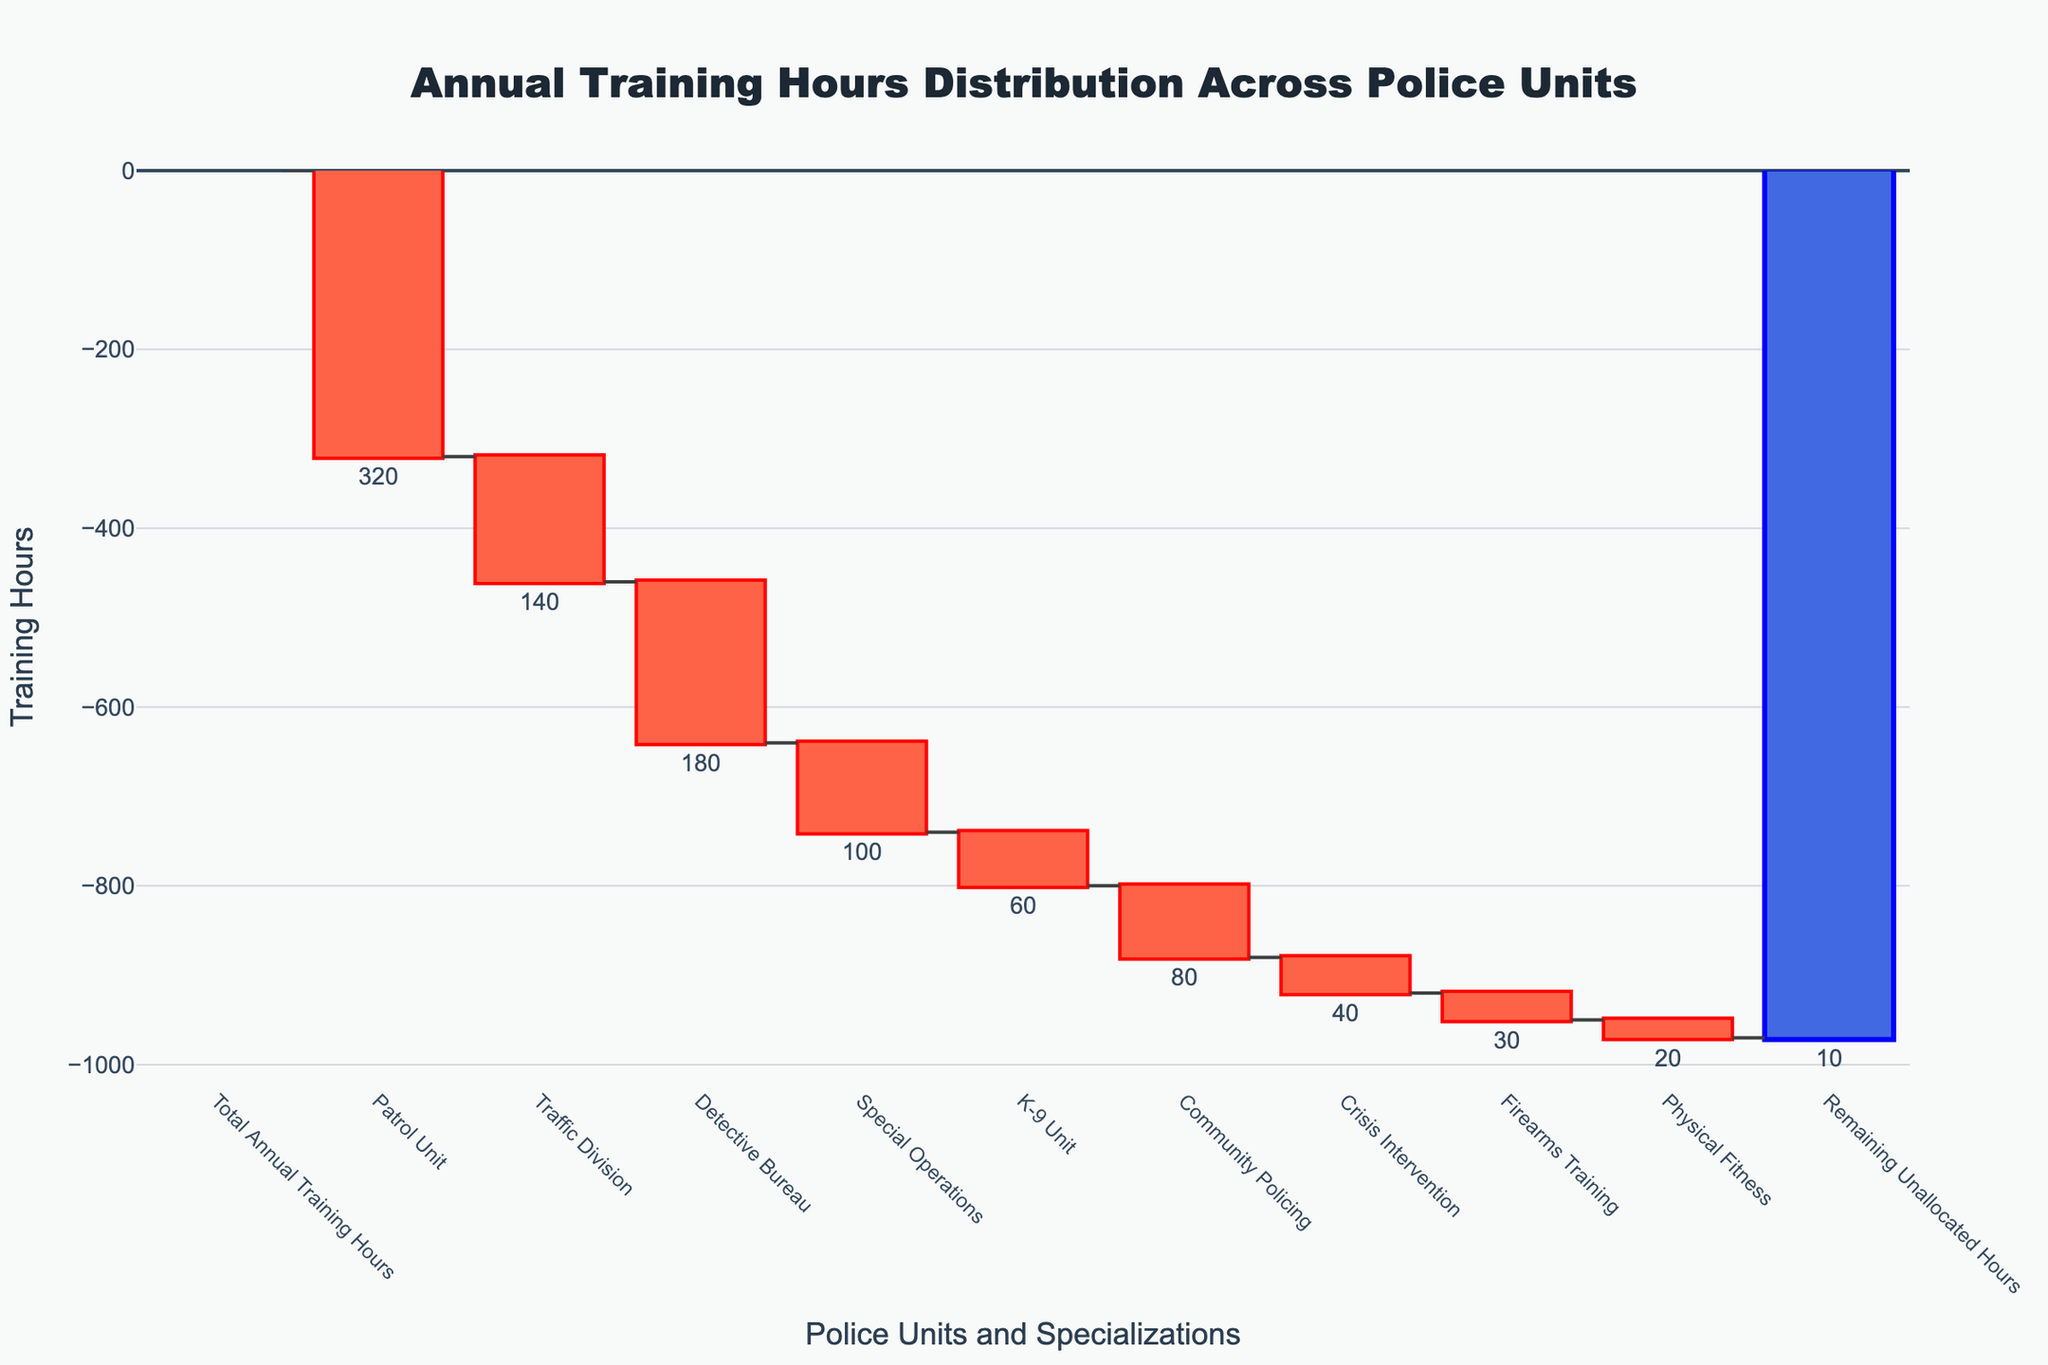What's the title of the chart? The title is prominently displayed at the top center of the chart in large font. It reads "Annual Training Hours Distribution Across Police Units".
Answer: Annual Training Hours Distribution Across Police Units What is the total amount of annual training hours? The total number of training hours is listed as the first category, "Total Annual Training Hours". The value is 960 hours.
Answer: 960 hours Which unit has the highest allocation of training hours? By examining the chart, the category with the largest drop in hours indicates the highest allocation. The "Patrol Unit" shows a decrease of 320 hours, which is the highest allocation among units.
Answer: Patrol Unit How many hours are allocated to Firearms Training? The Firearms Training category is listed and shows a decrease of 30 training hours.
Answer: 30 hours What is the sum of hours allocated to Physical Fitness and Crisis Intervention? Physical Fitness accounts for 20 hours and Crisis Intervention for 40 hours. Summing up these two values, 20 + 40 = 60 hours.
Answer: 60 hours Which unit has fewer training hours, the Traffic Division or the K-9 Unit? By comparing the two categories, the Traffic Division has a decrease of 140 hours, while the K-9 Unit has a decrease of 60 hours. Thus, the K-9 Unit has fewer training hours.
Answer: K-9 Unit What is the average number of hours allocated to Patrol, Detective Bureau, and Special Operations? Add the training hours for these three units: 320 (Patrol) + 180 (Detective Bureau) + 100 (Special Operations) = 600. Divide by the number of units: 600 / 3 = 200 hours.
Answer: 200 hours What is the overall effect of training allocations on the total hours? Starting from the total of 960 hours, sum up all deductions (320 + 140 + 180 + 100 + 60 + 80 + 40 + 30 + 20 + 10 = 980). This means the remaining unallocated hours reduce to 960 - 980 = -20, indicating an over-allocation.
Answer: Over-allocation by 20 hours How does the allocation to Community Policing compare to Special Operations? Community Policing has an allocation of 80 hours, while Special Operations has 100 hours. Special Operations receives more hours.
Answer: Special Operations receives more Which category had the smallest reduction in training hours? By examining all units and specializations, the category with the smallest reduction is "Remaining Unallocated Hours" with only a 10-hour reduction.
Answer: Remaining Unallocated Hours 